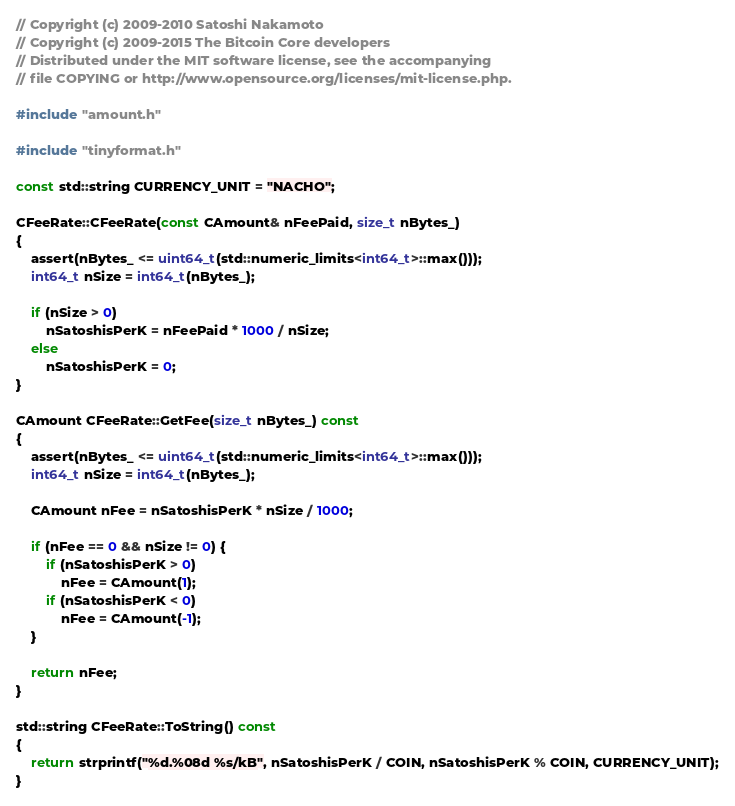Convert code to text. <code><loc_0><loc_0><loc_500><loc_500><_C++_>// Copyright (c) 2009-2010 Satoshi Nakamoto
// Copyright (c) 2009-2015 The Bitcoin Core developers
// Distributed under the MIT software license, see the accompanying
// file COPYING or http://www.opensource.org/licenses/mit-license.php.

#include "amount.h"

#include "tinyformat.h"

const std::string CURRENCY_UNIT = "NACHO";

CFeeRate::CFeeRate(const CAmount& nFeePaid, size_t nBytes_)
{
    assert(nBytes_ <= uint64_t(std::numeric_limits<int64_t>::max()));
    int64_t nSize = int64_t(nBytes_);

    if (nSize > 0)
        nSatoshisPerK = nFeePaid * 1000 / nSize;
    else
        nSatoshisPerK = 0;
}

CAmount CFeeRate::GetFee(size_t nBytes_) const
{
    assert(nBytes_ <= uint64_t(std::numeric_limits<int64_t>::max()));
    int64_t nSize = int64_t(nBytes_);

    CAmount nFee = nSatoshisPerK * nSize / 1000;

    if (nFee == 0 && nSize != 0) {
        if (nSatoshisPerK > 0)
            nFee = CAmount(1);
        if (nSatoshisPerK < 0)
            nFee = CAmount(-1);
    }

    return nFee;
}

std::string CFeeRate::ToString() const
{
    return strprintf("%d.%08d %s/kB", nSatoshisPerK / COIN, nSatoshisPerK % COIN, CURRENCY_UNIT);
}
</code> 